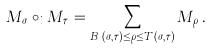<formula> <loc_0><loc_0><loc_500><loc_500>M _ { \sigma } \circ _ { i } M _ { \tau } = \sum _ { B _ { i } ( \sigma , \tau ) \leq \rho \leq T _ { i } ( \sigma , \tau ) } M _ { \rho } \, .</formula> 